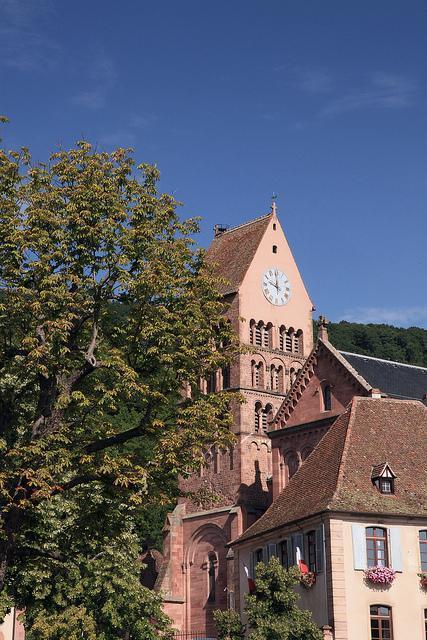How many clocks in this photo?
Give a very brief answer. 1. How many of the fruit that can be seen in the bowl are bananas?
Give a very brief answer. 0. 